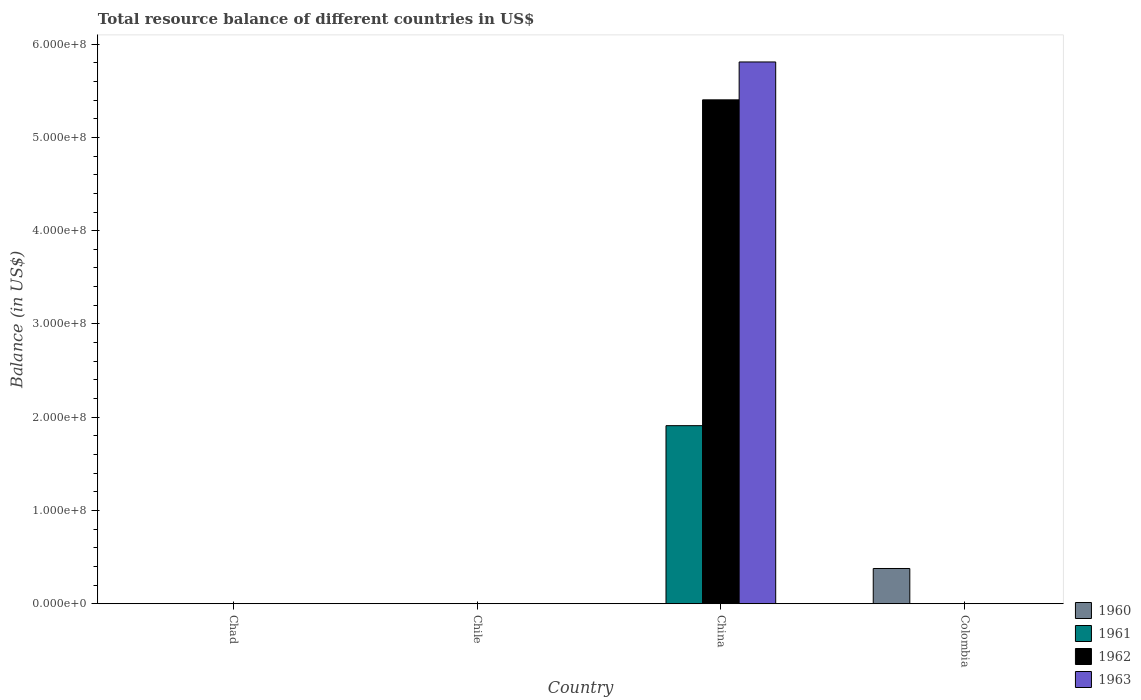How many different coloured bars are there?
Give a very brief answer. 4. Are the number of bars on each tick of the X-axis equal?
Give a very brief answer. No. What is the total resource balance in 1962 in Colombia?
Offer a very short reply. 0. Across all countries, what is the maximum total resource balance in 1961?
Offer a very short reply. 1.91e+08. Across all countries, what is the minimum total resource balance in 1963?
Your response must be concise. 0. In which country was the total resource balance in 1960 maximum?
Your response must be concise. Colombia. What is the total total resource balance in 1963 in the graph?
Make the answer very short. 5.81e+08. What is the difference between the total resource balance in 1961 in Chile and the total resource balance in 1963 in Colombia?
Ensure brevity in your answer.  0. What is the average total resource balance in 1962 per country?
Offer a very short reply. 1.35e+08. What is the difference between the total resource balance of/in 1961 and total resource balance of/in 1963 in China?
Ensure brevity in your answer.  -3.90e+08. What is the difference between the highest and the lowest total resource balance in 1961?
Your answer should be compact. 1.91e+08. In how many countries, is the total resource balance in 1963 greater than the average total resource balance in 1963 taken over all countries?
Make the answer very short. 1. Is it the case that in every country, the sum of the total resource balance in 1961 and total resource balance in 1962 is greater than the sum of total resource balance in 1963 and total resource balance in 1960?
Offer a very short reply. No. Is it the case that in every country, the sum of the total resource balance in 1962 and total resource balance in 1961 is greater than the total resource balance in 1960?
Your answer should be very brief. No. Does the graph contain grids?
Make the answer very short. No. How many legend labels are there?
Keep it short and to the point. 4. How are the legend labels stacked?
Give a very brief answer. Vertical. What is the title of the graph?
Offer a very short reply. Total resource balance of different countries in US$. What is the label or title of the Y-axis?
Provide a succinct answer. Balance (in US$). What is the Balance (in US$) in 1960 in Chad?
Your answer should be compact. 0. What is the Balance (in US$) in 1961 in Chad?
Offer a terse response. 0. What is the Balance (in US$) in 1960 in Chile?
Offer a terse response. 0. What is the Balance (in US$) in 1962 in Chile?
Provide a short and direct response. 0. What is the Balance (in US$) in 1960 in China?
Offer a very short reply. 0. What is the Balance (in US$) of 1961 in China?
Your response must be concise. 1.91e+08. What is the Balance (in US$) of 1962 in China?
Provide a succinct answer. 5.40e+08. What is the Balance (in US$) of 1963 in China?
Provide a succinct answer. 5.81e+08. What is the Balance (in US$) in 1960 in Colombia?
Your answer should be very brief. 3.78e+07. What is the Balance (in US$) of 1961 in Colombia?
Provide a short and direct response. 0. Across all countries, what is the maximum Balance (in US$) of 1960?
Offer a very short reply. 3.78e+07. Across all countries, what is the maximum Balance (in US$) in 1961?
Keep it short and to the point. 1.91e+08. Across all countries, what is the maximum Balance (in US$) of 1962?
Your answer should be compact. 5.40e+08. Across all countries, what is the maximum Balance (in US$) of 1963?
Give a very brief answer. 5.81e+08. Across all countries, what is the minimum Balance (in US$) in 1963?
Your answer should be very brief. 0. What is the total Balance (in US$) in 1960 in the graph?
Make the answer very short. 3.78e+07. What is the total Balance (in US$) of 1961 in the graph?
Offer a very short reply. 1.91e+08. What is the total Balance (in US$) in 1962 in the graph?
Your answer should be compact. 5.40e+08. What is the total Balance (in US$) in 1963 in the graph?
Keep it short and to the point. 5.81e+08. What is the average Balance (in US$) of 1960 per country?
Give a very brief answer. 9.44e+06. What is the average Balance (in US$) in 1961 per country?
Offer a very short reply. 4.77e+07. What is the average Balance (in US$) of 1962 per country?
Offer a terse response. 1.35e+08. What is the average Balance (in US$) of 1963 per country?
Make the answer very short. 1.45e+08. What is the difference between the Balance (in US$) of 1961 and Balance (in US$) of 1962 in China?
Keep it short and to the point. -3.49e+08. What is the difference between the Balance (in US$) in 1961 and Balance (in US$) in 1963 in China?
Provide a succinct answer. -3.90e+08. What is the difference between the Balance (in US$) of 1962 and Balance (in US$) of 1963 in China?
Keep it short and to the point. -4.06e+07. What is the difference between the highest and the lowest Balance (in US$) of 1960?
Make the answer very short. 3.78e+07. What is the difference between the highest and the lowest Balance (in US$) of 1961?
Make the answer very short. 1.91e+08. What is the difference between the highest and the lowest Balance (in US$) of 1962?
Offer a terse response. 5.40e+08. What is the difference between the highest and the lowest Balance (in US$) in 1963?
Give a very brief answer. 5.81e+08. 